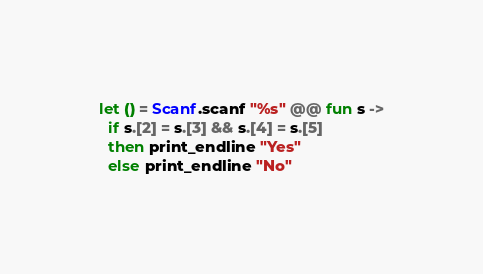Convert code to text. <code><loc_0><loc_0><loc_500><loc_500><_OCaml_>let () = Scanf.scanf "%s" @@ fun s ->
  if s.[2] = s.[3] && s.[4] = s.[5]
  then print_endline "Yes"
  else print_endline "No"</code> 